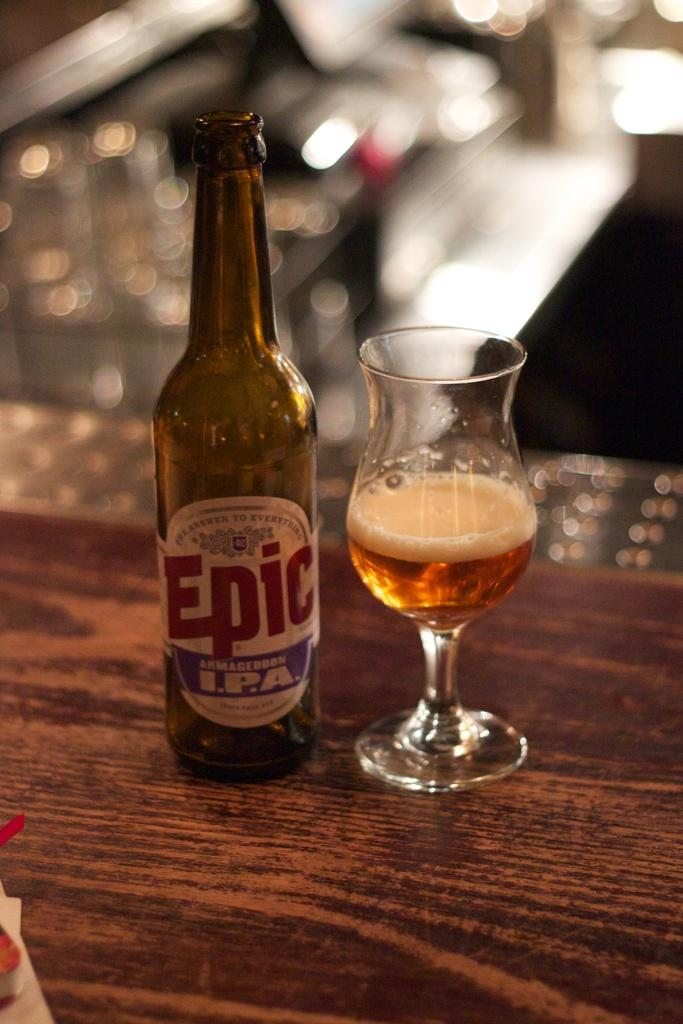<image>
Relay a brief, clear account of the picture shown. the word epic is on a bottle of alcohol 